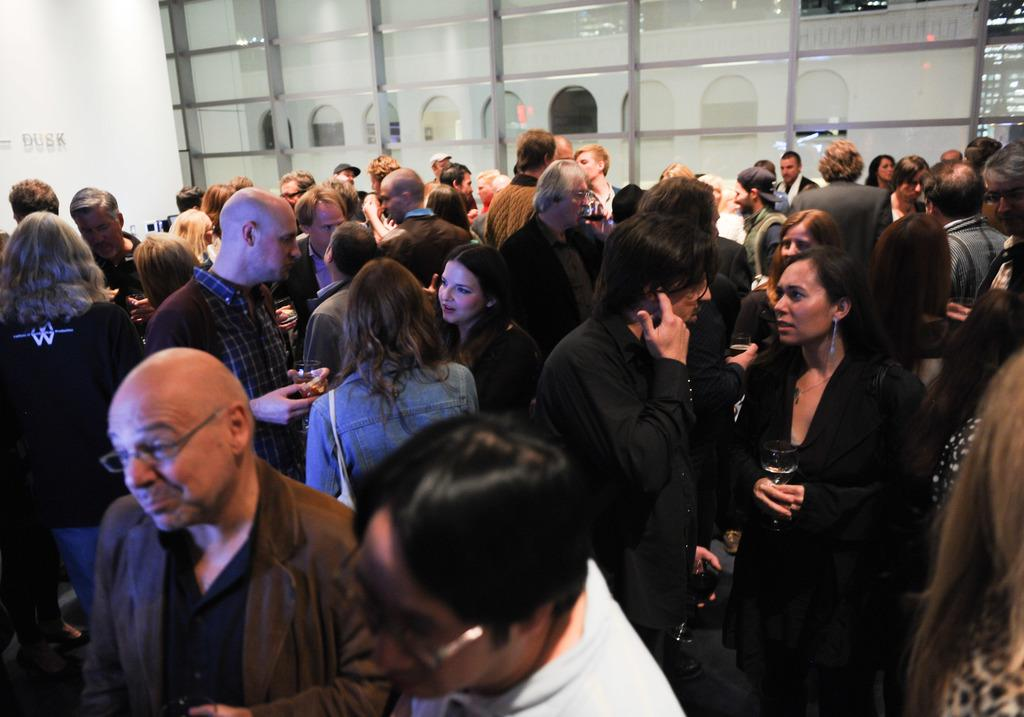What is happening in the image involving the group of people? The people in the image are standing and talking. Can you describe the setting or environment in which the people are interacting? There is a glass wall at the top of the image, which suggests that the people might be indoors or in a space with a transparent barrier. What type of fruit can be seen being sorted by the fairies in the image? There are no fairies or fruit present in the image; it features a group of people standing and talking near a glass wall. 